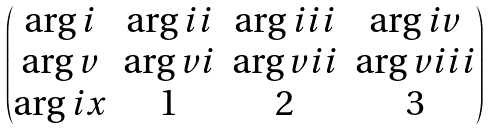Convert formula to latex. <formula><loc_0><loc_0><loc_500><loc_500>\begin{pmatrix} \arg i & \arg i i & \arg i i i & \arg i v \\ \arg v & \arg v i & \arg v i i & \arg v i i i \\ \arg i x & 1 & 2 & 3 \end{pmatrix}</formula> 